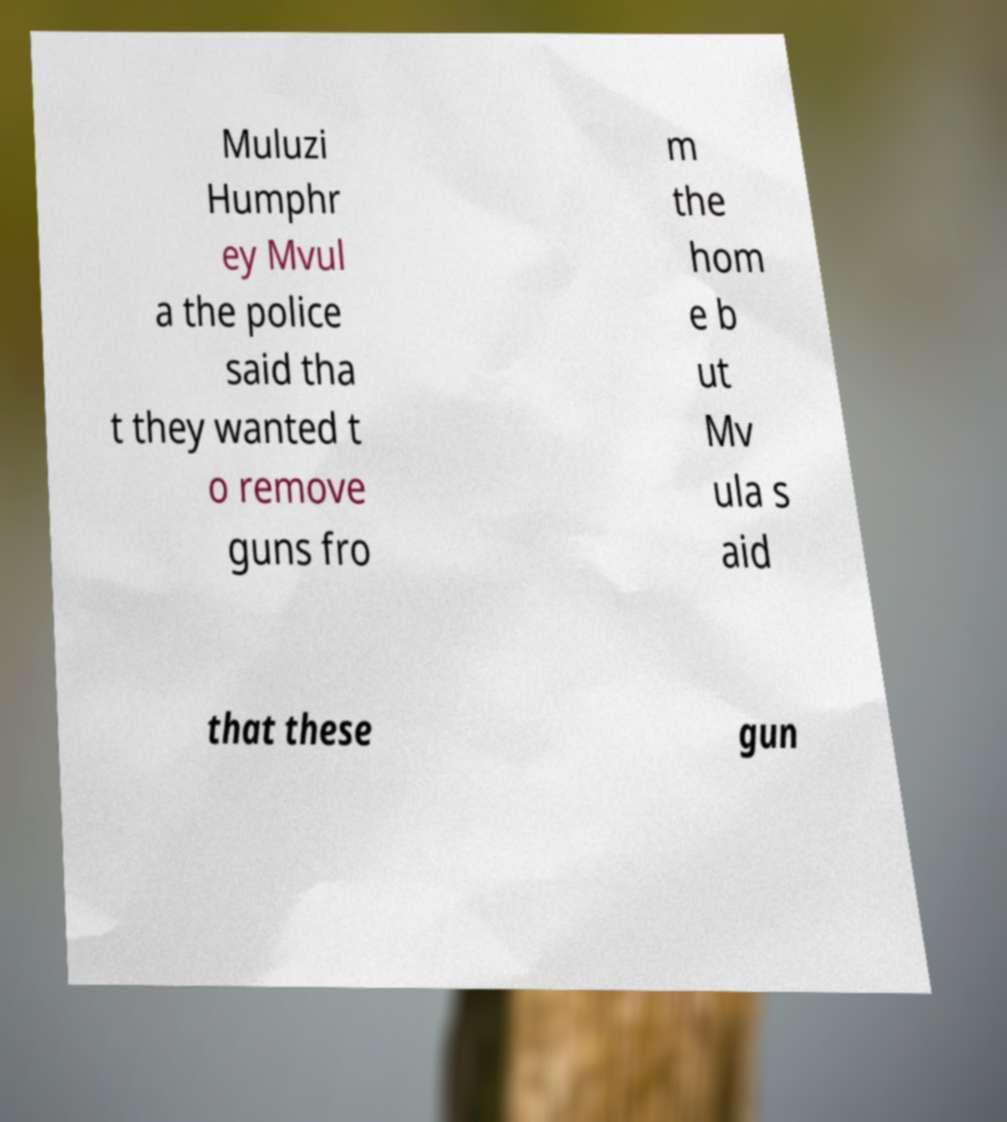Please identify and transcribe the text found in this image. Muluzi Humphr ey Mvul a the police said tha t they wanted t o remove guns fro m the hom e b ut Mv ula s aid that these gun 